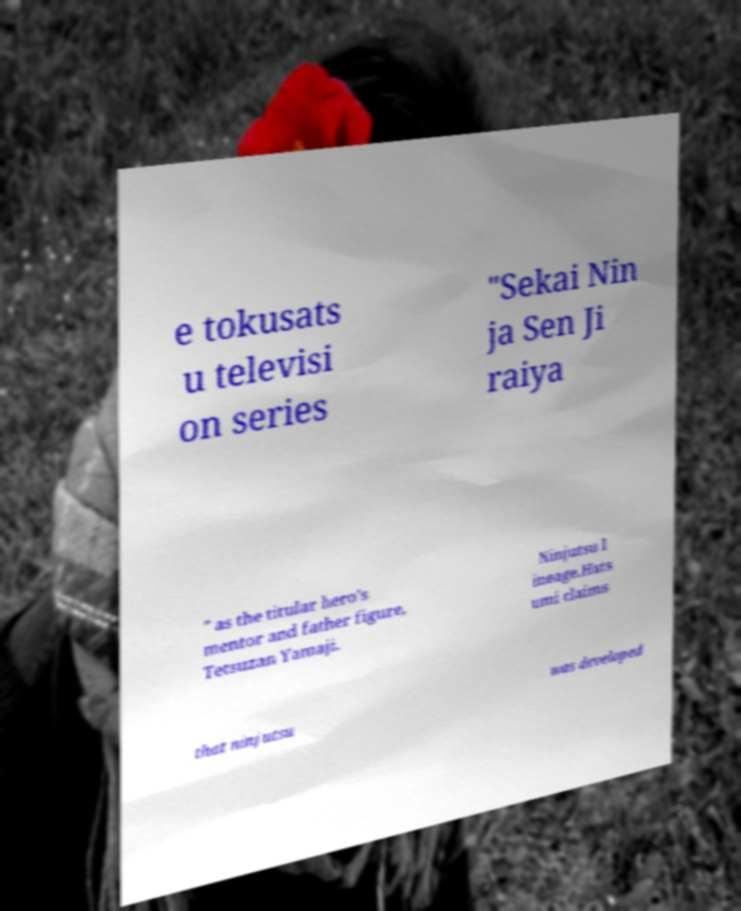Could you extract and type out the text from this image? e tokusats u televisi on series "Sekai Nin ja Sen Ji raiya " as the titular hero's mentor and father figure, Tetsuzan Yamaji. Ninjutsu l ineage.Hats umi claims that ninjutsu was developed 